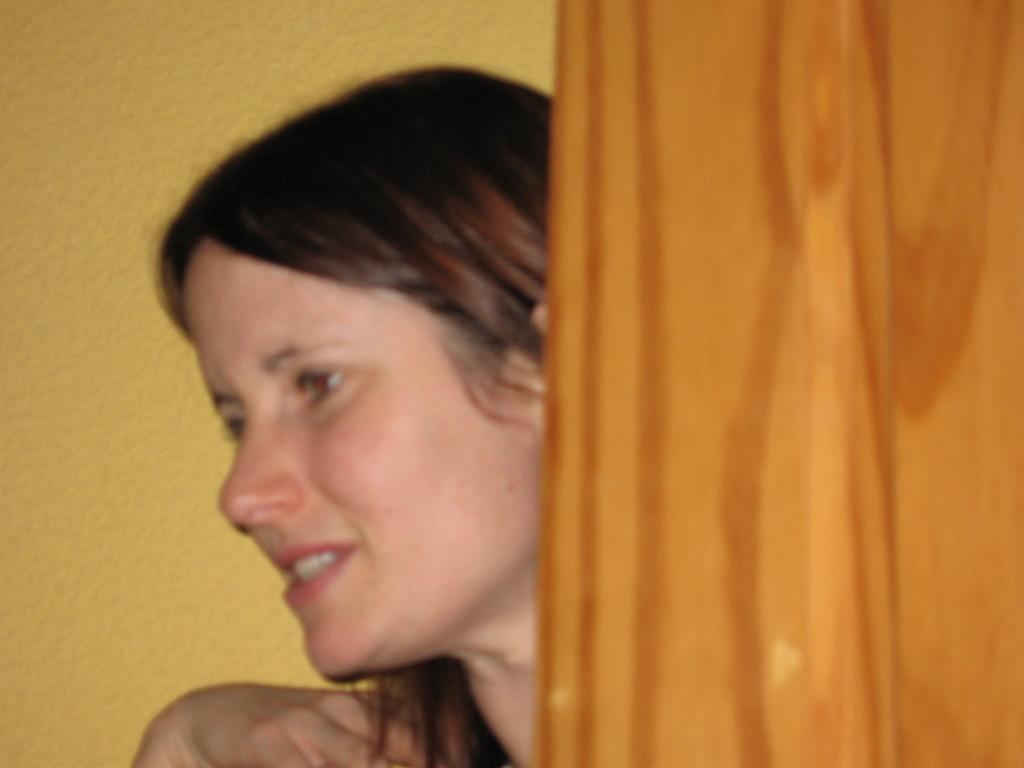What is the main subject in the image? There is a lady standing in the image. What can be seen behind the lady? There is a yellow wall in the background of the image. Is there any architectural feature visible in the image? Yes, there is a door in the image. What type of card is the lady holding in the image? There is no card present in the image. What type of glove is the lady wearing in the image? There is no glove present in the image. 